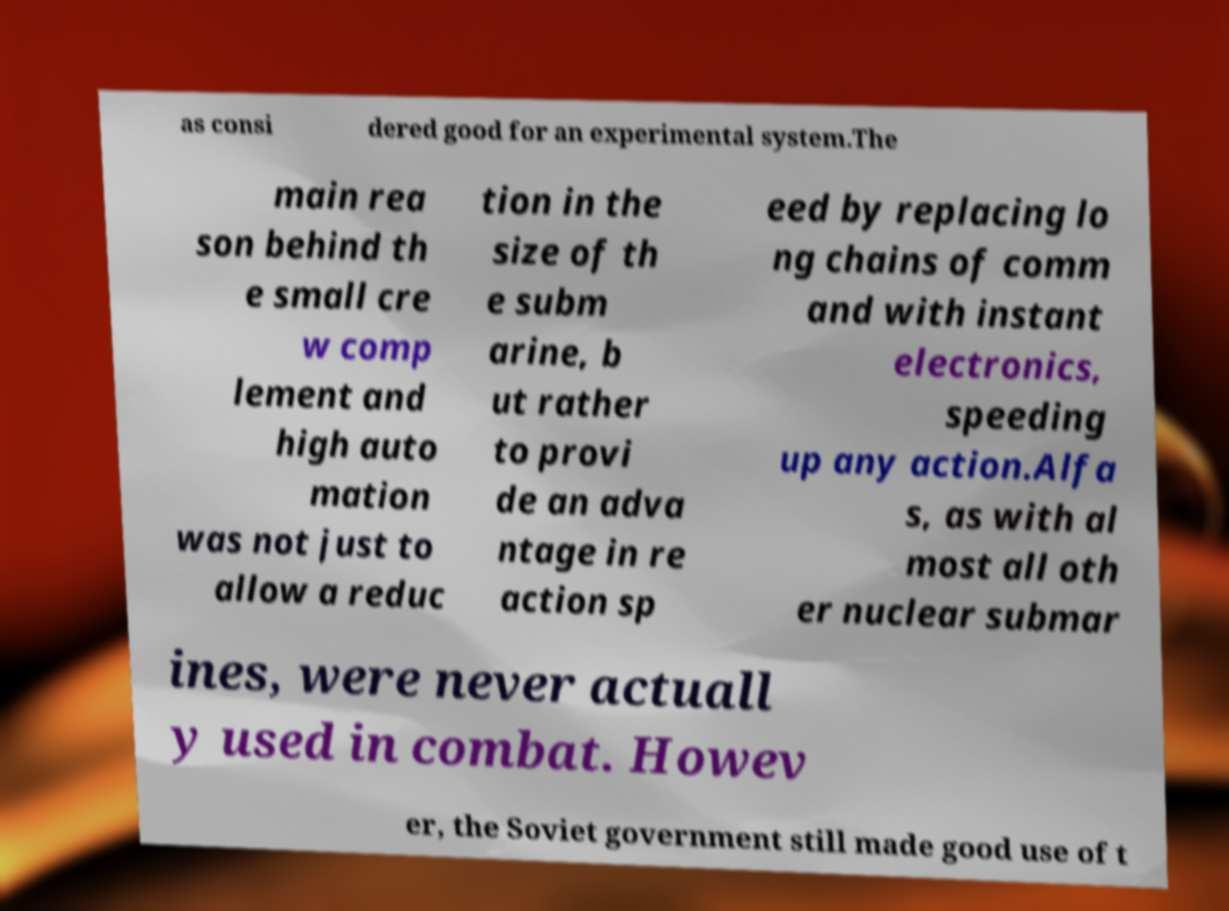What messages or text are displayed in this image? I need them in a readable, typed format. as consi dered good for an experimental system.The main rea son behind th e small cre w comp lement and high auto mation was not just to allow a reduc tion in the size of th e subm arine, b ut rather to provi de an adva ntage in re action sp eed by replacing lo ng chains of comm and with instant electronics, speeding up any action.Alfa s, as with al most all oth er nuclear submar ines, were never actuall y used in combat. Howev er, the Soviet government still made good use of t 